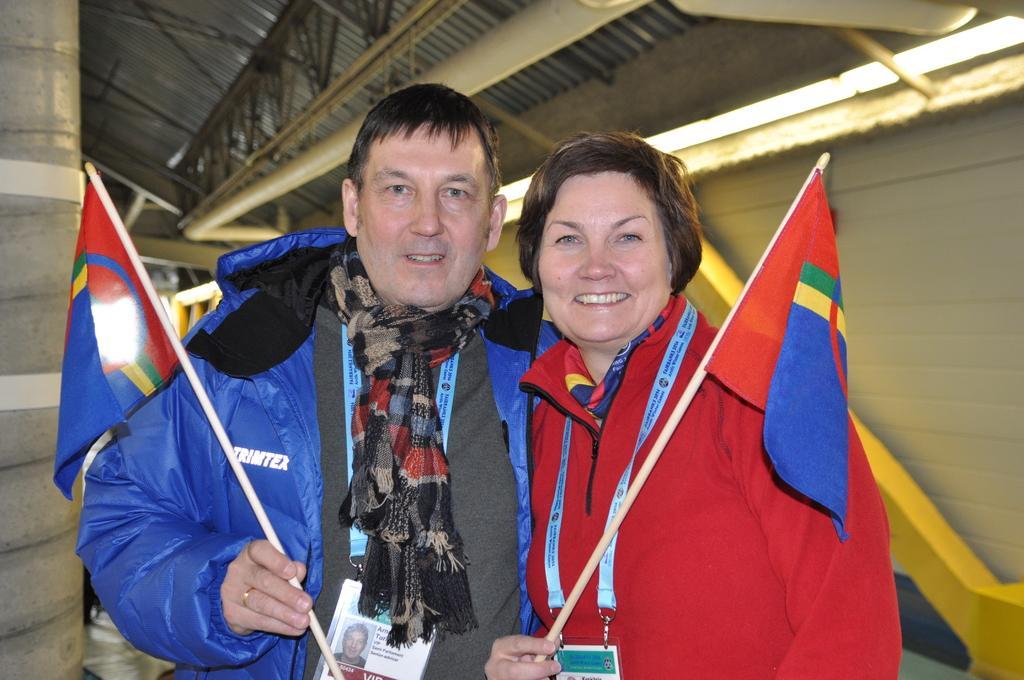Describe this image in one or two sentences. On the left side, there is a person in a blue color jacket, holding a flag, smiling and standing. Beside him, there is a woman in a red color jacket, holding a flag with a hand, smiling and standing. In the background, there are lights attached to the roof, there is a wall, a pillar and there is a pipe attached to the roof. 